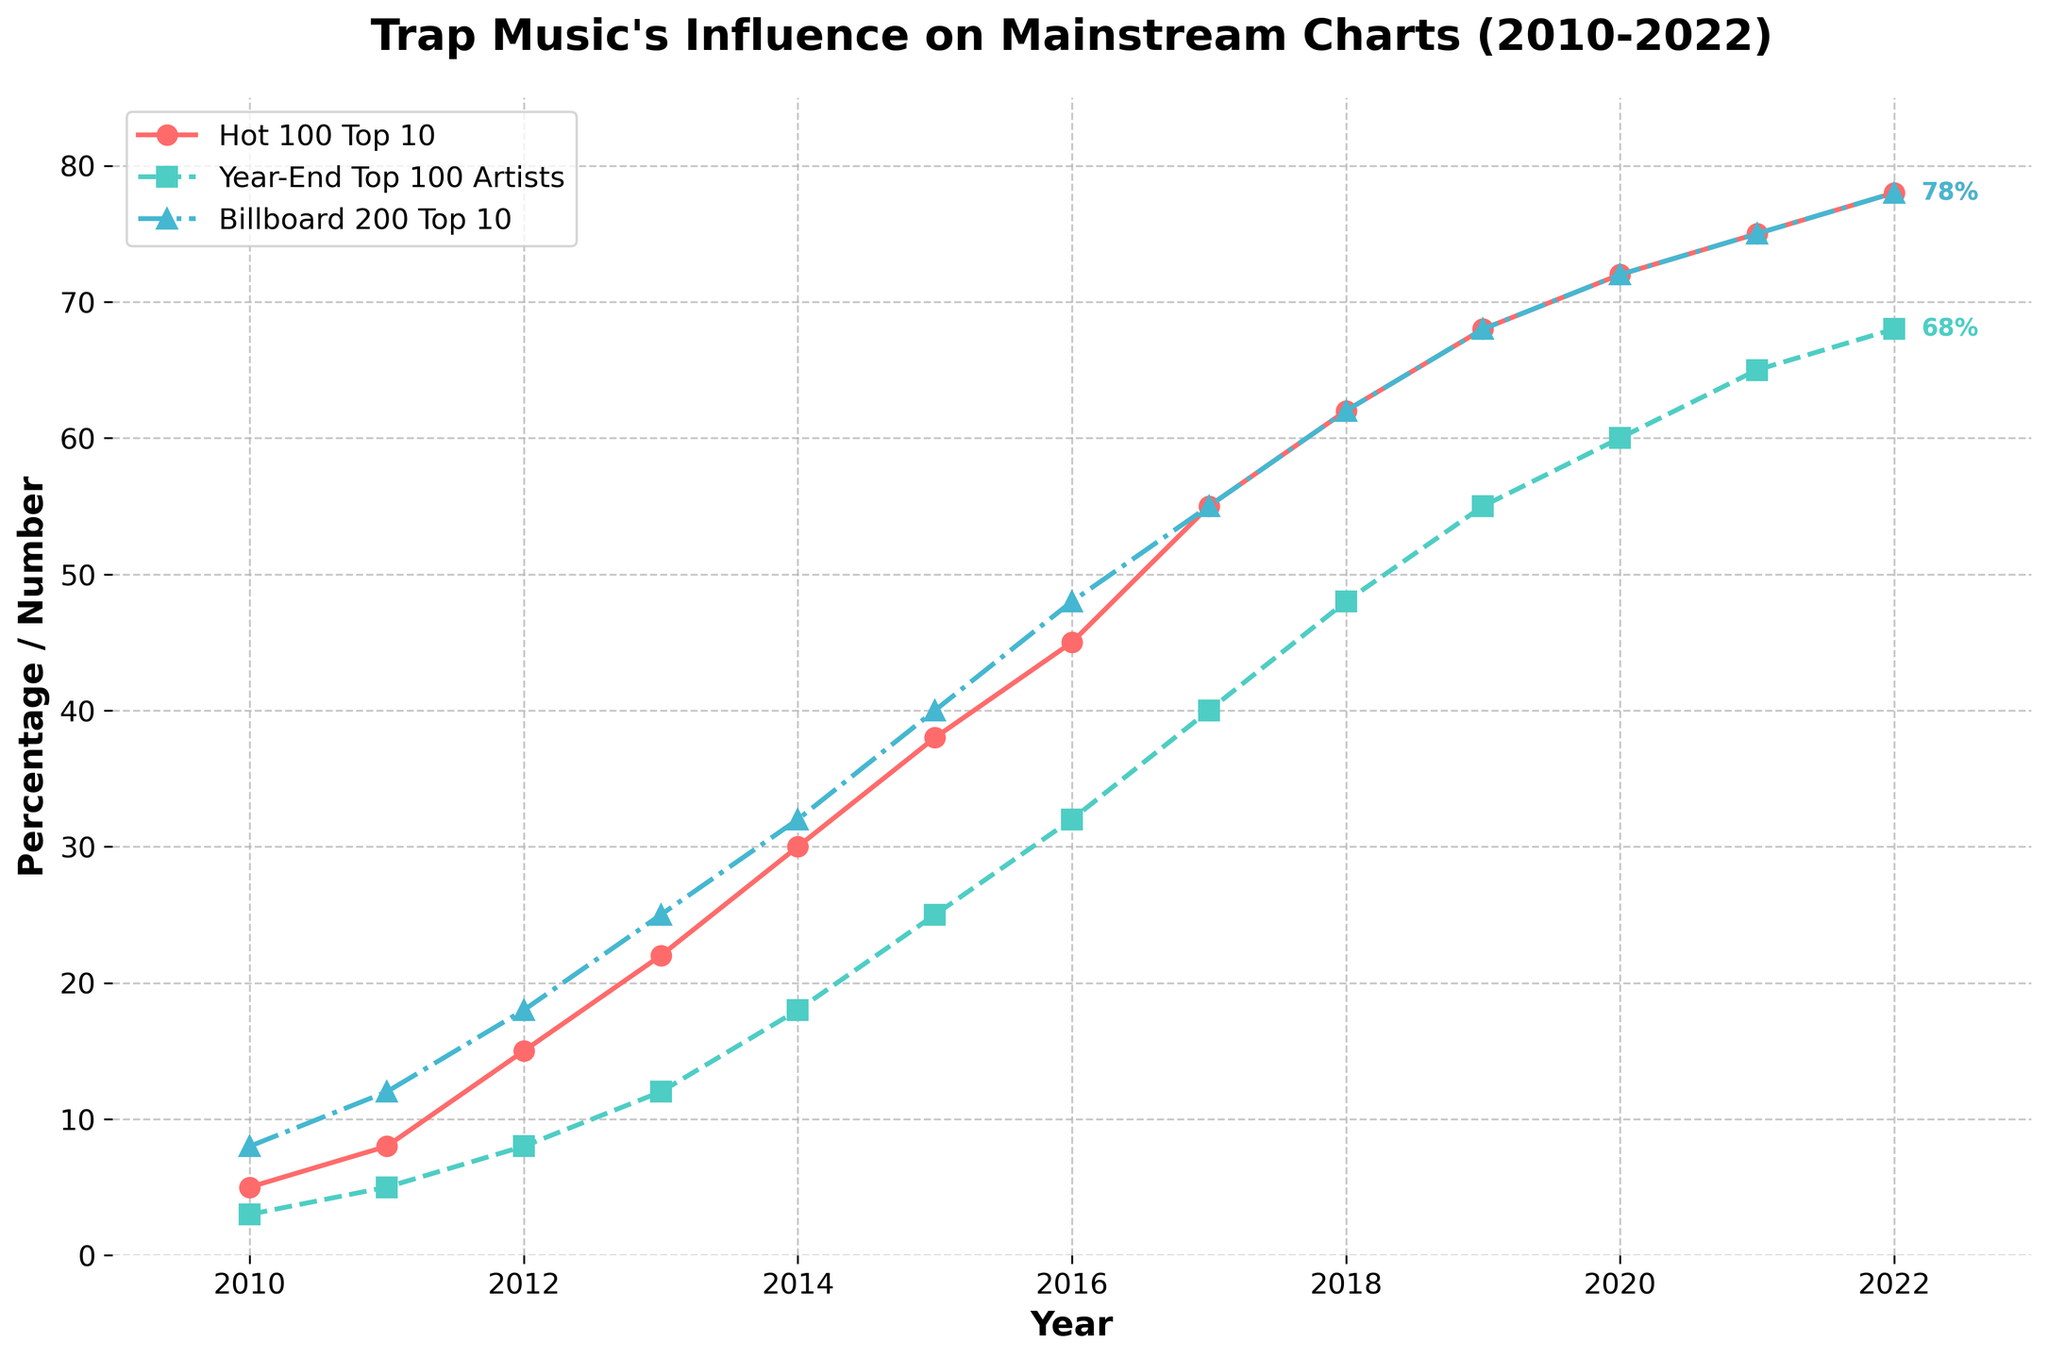Which year had the highest percentage of Trap Songs in Billboard Hot 100 Top 10? The line plotted with circles represents Trap Songs in Billboard Hot 100 Top 10. By following the line, the highest point is in the year 2022.
Answer: 2022 How many Trap Artists were in Billboard Year-End Top 100 Artists in 2015? The line plotted with squares represents Trap Artists in Billboard Year-End Top 100 Artists. In 2015, the value is 25.
Answer: 25 What is the difference in percentage of Trap Albums in Billboard 200 Top 10 between 2016 and 2018? Locate the values on the line plotted with triangles for the years 2016 and 2018. The values are 48% and 62%, respectively. The difference is 62 - 48 = 14.
Answer: 14% Which category showed the most significant increase from 2010 to 2022? Look at all three lines (circles for Hot 100 Top 10, squares for Year-End Top 100 Artists, and triangles for Billboard 200 Top 10). Calculate the increase for each: 
   - Hot 100 Top 10: 78 - 5 = 73
   - Year-End Top 100 Artists: 68 - 3 = 65 
   - Billboard 200 Top 10: 78 - 8 = 70. 
The Hot 100 Top 10 showed the most significant increase (73%).
Answer: Hot 100 Top 10 Which year did Trap Songs in Billboard Hot 100 Top 10 exceed 50% for the first time? Trace the line with circles to find when it first crosses the 50% mark. It occurs between 2016 (45%) and 2017 (55%). So, the first year exceeding 50% is 2017.
Answer: 2017 Compare the trends for Trap Artists in Billboard Year-End Top 100 Artists and Trap Albums in Billboard 200 Top 10 from 2010 to 2022. Which category had a more consistent increase? Examine both the squares and the triangles lines. Both lines show a general upward trend. However, the smoothness of the squares line suggests a more consistent increase, whereas the triangles line has slightly more fluctuations.
Answer: Billboard Year-End Top 100 Artists If we consider the linear growth between 2012 and 2014, what was the average yearly increase in percentage of Trap Songs in Billboard Hot 100 Top 10 during this period? The values in 2012 and 2014 are 15% and 30%, respectively. Calculate the difference (30 - 15 = 15) and divide by the number of years (2014 - 2012 = 2). The average yearly increase is 15 / 2 = 7.5.
Answer: 7.5% Which year had the same percentage for both Trap Songs in Billboard Hot 100 Top 10 and Trap Albums in Billboard 200 Top 10? Identify the year when the circle and triangle lines intersect. Both lines reach 78% in 2022.
Answer: 2022 